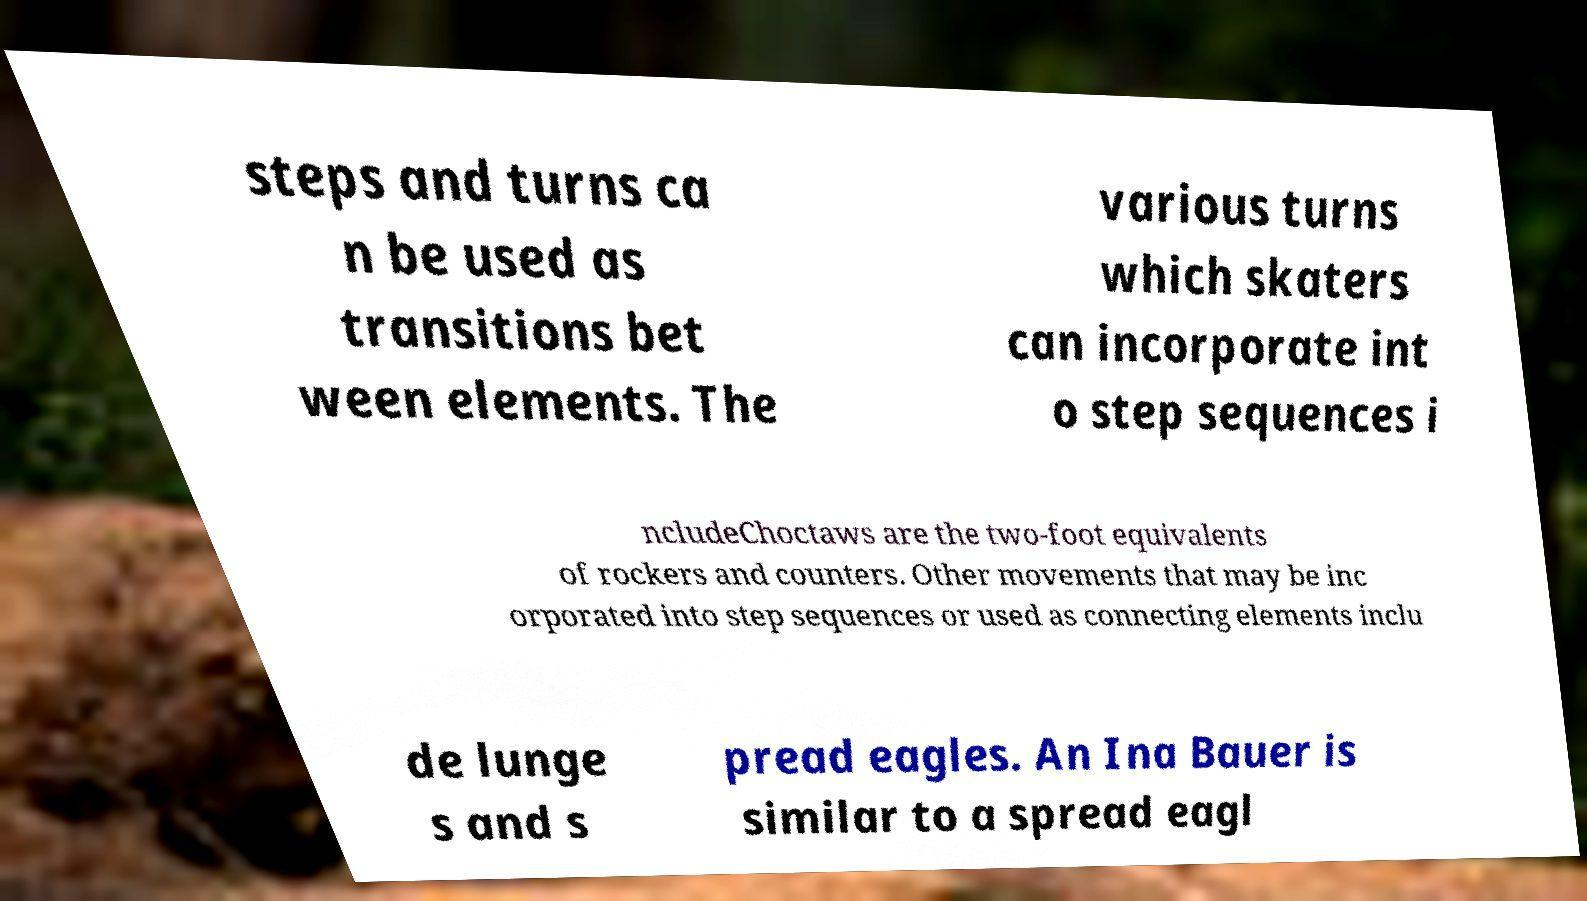There's text embedded in this image that I need extracted. Can you transcribe it verbatim? steps and turns ca n be used as transitions bet ween elements. The various turns which skaters can incorporate int o step sequences i ncludeChoctaws are the two-foot equivalents of rockers and counters. Other movements that may be inc orporated into step sequences or used as connecting elements inclu de lunge s and s pread eagles. An Ina Bauer is similar to a spread eagl 